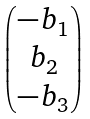Convert formula to latex. <formula><loc_0><loc_0><loc_500><loc_500>\begin{pmatrix} - b _ { 1 } \\ b _ { 2 } \\ - b _ { 3 } \end{pmatrix}</formula> 